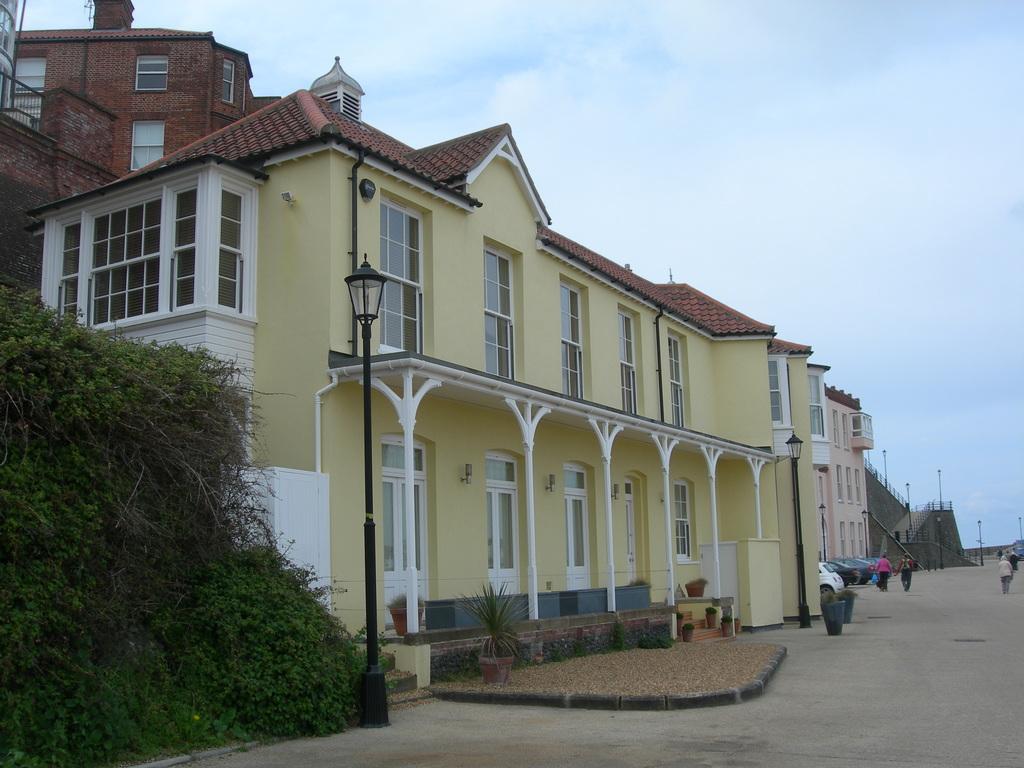Please provide a concise description of this image. These are the buildings with the windows. I can see the street lights. These look like the flower pots with the plants in it. On the left side of the image, I can see the trees. I can see few people standing. I think these are the cars, which are parked. Here is the sky. 